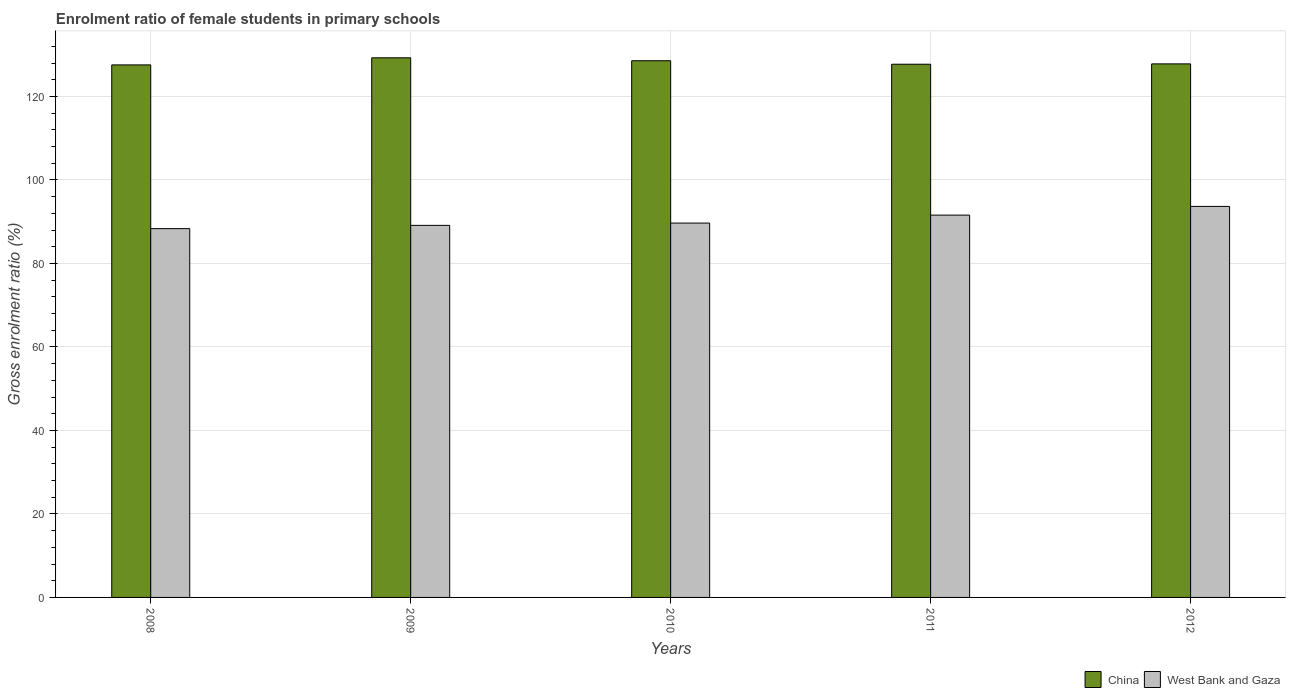How many bars are there on the 3rd tick from the right?
Offer a very short reply. 2. What is the enrolment ratio of female students in primary schools in China in 2012?
Provide a succinct answer. 127.79. Across all years, what is the maximum enrolment ratio of female students in primary schools in China?
Ensure brevity in your answer.  129.24. Across all years, what is the minimum enrolment ratio of female students in primary schools in West Bank and Gaza?
Give a very brief answer. 88.33. In which year was the enrolment ratio of female students in primary schools in West Bank and Gaza minimum?
Give a very brief answer. 2008. What is the total enrolment ratio of female students in primary schools in West Bank and Gaza in the graph?
Offer a very short reply. 452.32. What is the difference between the enrolment ratio of female students in primary schools in China in 2008 and that in 2012?
Your response must be concise. -0.24. What is the difference between the enrolment ratio of female students in primary schools in China in 2008 and the enrolment ratio of female students in primary schools in West Bank and Gaza in 2009?
Your answer should be very brief. 38.43. What is the average enrolment ratio of female students in primary schools in China per year?
Provide a short and direct response. 128.17. In the year 2008, what is the difference between the enrolment ratio of female students in primary schools in West Bank and Gaza and enrolment ratio of female students in primary schools in China?
Your response must be concise. -39.22. In how many years, is the enrolment ratio of female students in primary schools in China greater than 104 %?
Give a very brief answer. 5. What is the ratio of the enrolment ratio of female students in primary schools in West Bank and Gaza in 2008 to that in 2009?
Make the answer very short. 0.99. Is the enrolment ratio of female students in primary schools in West Bank and Gaza in 2009 less than that in 2011?
Ensure brevity in your answer.  Yes. Is the difference between the enrolment ratio of female students in primary schools in West Bank and Gaza in 2008 and 2011 greater than the difference between the enrolment ratio of female students in primary schools in China in 2008 and 2011?
Provide a succinct answer. No. What is the difference between the highest and the second highest enrolment ratio of female students in primary schools in West Bank and Gaza?
Make the answer very short. 2.09. What is the difference between the highest and the lowest enrolment ratio of female students in primary schools in China?
Make the answer very short. 1.7. Is the sum of the enrolment ratio of female students in primary schools in China in 2008 and 2012 greater than the maximum enrolment ratio of female students in primary schools in West Bank and Gaza across all years?
Your response must be concise. Yes. What does the 2nd bar from the left in 2012 represents?
Your answer should be compact. West Bank and Gaza. How many bars are there?
Provide a short and direct response. 10. Are all the bars in the graph horizontal?
Make the answer very short. No. How many years are there in the graph?
Offer a very short reply. 5. What is the difference between two consecutive major ticks on the Y-axis?
Your answer should be compact. 20. Are the values on the major ticks of Y-axis written in scientific E-notation?
Your answer should be very brief. No. Where does the legend appear in the graph?
Your answer should be compact. Bottom right. How are the legend labels stacked?
Ensure brevity in your answer.  Horizontal. What is the title of the graph?
Provide a succinct answer. Enrolment ratio of female students in primary schools. Does "Benin" appear as one of the legend labels in the graph?
Give a very brief answer. No. What is the Gross enrolment ratio (%) of China in 2008?
Provide a succinct answer. 127.54. What is the Gross enrolment ratio (%) in West Bank and Gaza in 2008?
Make the answer very short. 88.33. What is the Gross enrolment ratio (%) of China in 2009?
Your answer should be very brief. 129.24. What is the Gross enrolment ratio (%) in West Bank and Gaza in 2009?
Offer a terse response. 89.11. What is the Gross enrolment ratio (%) of China in 2010?
Your answer should be compact. 128.54. What is the Gross enrolment ratio (%) in West Bank and Gaza in 2010?
Give a very brief answer. 89.66. What is the Gross enrolment ratio (%) of China in 2011?
Your answer should be very brief. 127.71. What is the Gross enrolment ratio (%) in West Bank and Gaza in 2011?
Make the answer very short. 91.57. What is the Gross enrolment ratio (%) of China in 2012?
Provide a succinct answer. 127.79. What is the Gross enrolment ratio (%) in West Bank and Gaza in 2012?
Your answer should be very brief. 93.65. Across all years, what is the maximum Gross enrolment ratio (%) in China?
Make the answer very short. 129.24. Across all years, what is the maximum Gross enrolment ratio (%) of West Bank and Gaza?
Your response must be concise. 93.65. Across all years, what is the minimum Gross enrolment ratio (%) in China?
Provide a short and direct response. 127.54. Across all years, what is the minimum Gross enrolment ratio (%) in West Bank and Gaza?
Your response must be concise. 88.33. What is the total Gross enrolment ratio (%) of China in the graph?
Keep it short and to the point. 640.83. What is the total Gross enrolment ratio (%) of West Bank and Gaza in the graph?
Provide a short and direct response. 452.32. What is the difference between the Gross enrolment ratio (%) in China in 2008 and that in 2009?
Give a very brief answer. -1.7. What is the difference between the Gross enrolment ratio (%) in West Bank and Gaza in 2008 and that in 2009?
Your response must be concise. -0.78. What is the difference between the Gross enrolment ratio (%) of China in 2008 and that in 2010?
Give a very brief answer. -1. What is the difference between the Gross enrolment ratio (%) of West Bank and Gaza in 2008 and that in 2010?
Offer a terse response. -1.33. What is the difference between the Gross enrolment ratio (%) in China in 2008 and that in 2011?
Ensure brevity in your answer.  -0.16. What is the difference between the Gross enrolment ratio (%) in West Bank and Gaza in 2008 and that in 2011?
Your answer should be very brief. -3.24. What is the difference between the Gross enrolment ratio (%) of China in 2008 and that in 2012?
Provide a short and direct response. -0.24. What is the difference between the Gross enrolment ratio (%) in West Bank and Gaza in 2008 and that in 2012?
Make the answer very short. -5.33. What is the difference between the Gross enrolment ratio (%) of China in 2009 and that in 2010?
Give a very brief answer. 0.7. What is the difference between the Gross enrolment ratio (%) of West Bank and Gaza in 2009 and that in 2010?
Ensure brevity in your answer.  -0.55. What is the difference between the Gross enrolment ratio (%) of China in 2009 and that in 2011?
Give a very brief answer. 1.54. What is the difference between the Gross enrolment ratio (%) of West Bank and Gaza in 2009 and that in 2011?
Offer a very short reply. -2.46. What is the difference between the Gross enrolment ratio (%) of China in 2009 and that in 2012?
Your answer should be very brief. 1.46. What is the difference between the Gross enrolment ratio (%) of West Bank and Gaza in 2009 and that in 2012?
Keep it short and to the point. -4.54. What is the difference between the Gross enrolment ratio (%) in China in 2010 and that in 2011?
Offer a terse response. 0.83. What is the difference between the Gross enrolment ratio (%) of West Bank and Gaza in 2010 and that in 2011?
Your answer should be compact. -1.91. What is the difference between the Gross enrolment ratio (%) in China in 2010 and that in 2012?
Offer a terse response. 0.75. What is the difference between the Gross enrolment ratio (%) in West Bank and Gaza in 2010 and that in 2012?
Ensure brevity in your answer.  -3.99. What is the difference between the Gross enrolment ratio (%) of China in 2011 and that in 2012?
Your response must be concise. -0.08. What is the difference between the Gross enrolment ratio (%) in West Bank and Gaza in 2011 and that in 2012?
Your response must be concise. -2.09. What is the difference between the Gross enrolment ratio (%) of China in 2008 and the Gross enrolment ratio (%) of West Bank and Gaza in 2009?
Make the answer very short. 38.43. What is the difference between the Gross enrolment ratio (%) in China in 2008 and the Gross enrolment ratio (%) in West Bank and Gaza in 2010?
Give a very brief answer. 37.88. What is the difference between the Gross enrolment ratio (%) of China in 2008 and the Gross enrolment ratio (%) of West Bank and Gaza in 2011?
Give a very brief answer. 35.98. What is the difference between the Gross enrolment ratio (%) of China in 2008 and the Gross enrolment ratio (%) of West Bank and Gaza in 2012?
Provide a short and direct response. 33.89. What is the difference between the Gross enrolment ratio (%) of China in 2009 and the Gross enrolment ratio (%) of West Bank and Gaza in 2010?
Your answer should be very brief. 39.58. What is the difference between the Gross enrolment ratio (%) in China in 2009 and the Gross enrolment ratio (%) in West Bank and Gaza in 2011?
Ensure brevity in your answer.  37.68. What is the difference between the Gross enrolment ratio (%) of China in 2009 and the Gross enrolment ratio (%) of West Bank and Gaza in 2012?
Give a very brief answer. 35.59. What is the difference between the Gross enrolment ratio (%) of China in 2010 and the Gross enrolment ratio (%) of West Bank and Gaza in 2011?
Offer a terse response. 36.97. What is the difference between the Gross enrolment ratio (%) of China in 2010 and the Gross enrolment ratio (%) of West Bank and Gaza in 2012?
Your answer should be very brief. 34.89. What is the difference between the Gross enrolment ratio (%) of China in 2011 and the Gross enrolment ratio (%) of West Bank and Gaza in 2012?
Your response must be concise. 34.05. What is the average Gross enrolment ratio (%) of China per year?
Make the answer very short. 128.17. What is the average Gross enrolment ratio (%) of West Bank and Gaza per year?
Offer a very short reply. 90.46. In the year 2008, what is the difference between the Gross enrolment ratio (%) in China and Gross enrolment ratio (%) in West Bank and Gaza?
Make the answer very short. 39.22. In the year 2009, what is the difference between the Gross enrolment ratio (%) of China and Gross enrolment ratio (%) of West Bank and Gaza?
Offer a very short reply. 40.13. In the year 2010, what is the difference between the Gross enrolment ratio (%) of China and Gross enrolment ratio (%) of West Bank and Gaza?
Keep it short and to the point. 38.88. In the year 2011, what is the difference between the Gross enrolment ratio (%) of China and Gross enrolment ratio (%) of West Bank and Gaza?
Your answer should be compact. 36.14. In the year 2012, what is the difference between the Gross enrolment ratio (%) of China and Gross enrolment ratio (%) of West Bank and Gaza?
Your answer should be compact. 34.13. What is the ratio of the Gross enrolment ratio (%) of China in 2008 to that in 2009?
Provide a short and direct response. 0.99. What is the ratio of the Gross enrolment ratio (%) of West Bank and Gaza in 2008 to that in 2009?
Provide a short and direct response. 0.99. What is the ratio of the Gross enrolment ratio (%) of China in 2008 to that in 2010?
Provide a succinct answer. 0.99. What is the ratio of the Gross enrolment ratio (%) in West Bank and Gaza in 2008 to that in 2010?
Your answer should be compact. 0.99. What is the ratio of the Gross enrolment ratio (%) of China in 2008 to that in 2011?
Offer a terse response. 1. What is the ratio of the Gross enrolment ratio (%) of West Bank and Gaza in 2008 to that in 2011?
Give a very brief answer. 0.96. What is the ratio of the Gross enrolment ratio (%) in West Bank and Gaza in 2008 to that in 2012?
Provide a succinct answer. 0.94. What is the ratio of the Gross enrolment ratio (%) of China in 2009 to that in 2010?
Your response must be concise. 1.01. What is the ratio of the Gross enrolment ratio (%) of West Bank and Gaza in 2009 to that in 2010?
Your response must be concise. 0.99. What is the ratio of the Gross enrolment ratio (%) of China in 2009 to that in 2011?
Ensure brevity in your answer.  1.01. What is the ratio of the Gross enrolment ratio (%) of West Bank and Gaza in 2009 to that in 2011?
Offer a very short reply. 0.97. What is the ratio of the Gross enrolment ratio (%) of China in 2009 to that in 2012?
Your answer should be compact. 1.01. What is the ratio of the Gross enrolment ratio (%) of West Bank and Gaza in 2009 to that in 2012?
Give a very brief answer. 0.95. What is the ratio of the Gross enrolment ratio (%) in West Bank and Gaza in 2010 to that in 2011?
Your answer should be very brief. 0.98. What is the ratio of the Gross enrolment ratio (%) in China in 2010 to that in 2012?
Provide a succinct answer. 1.01. What is the ratio of the Gross enrolment ratio (%) of West Bank and Gaza in 2010 to that in 2012?
Provide a short and direct response. 0.96. What is the ratio of the Gross enrolment ratio (%) of China in 2011 to that in 2012?
Offer a very short reply. 1. What is the ratio of the Gross enrolment ratio (%) in West Bank and Gaza in 2011 to that in 2012?
Provide a succinct answer. 0.98. What is the difference between the highest and the second highest Gross enrolment ratio (%) in China?
Provide a short and direct response. 0.7. What is the difference between the highest and the second highest Gross enrolment ratio (%) in West Bank and Gaza?
Provide a succinct answer. 2.09. What is the difference between the highest and the lowest Gross enrolment ratio (%) of China?
Offer a terse response. 1.7. What is the difference between the highest and the lowest Gross enrolment ratio (%) in West Bank and Gaza?
Your answer should be compact. 5.33. 